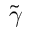Convert formula to latex. <formula><loc_0><loc_0><loc_500><loc_500>\tilde { \gamma }</formula> 